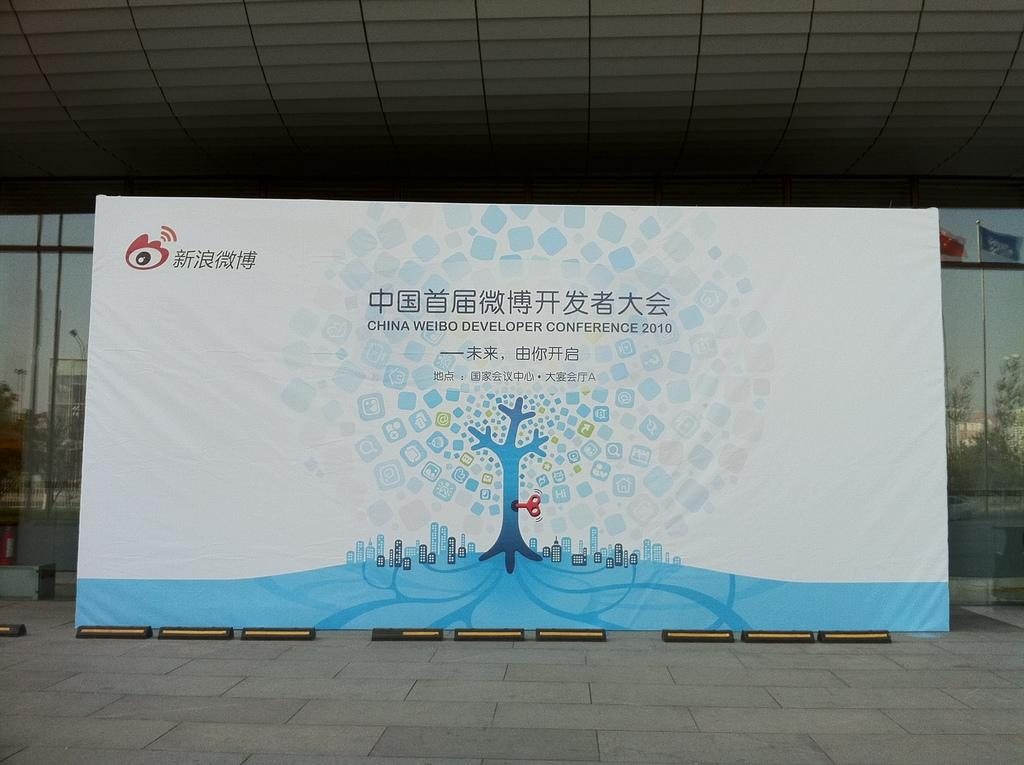What is the main object in the image? There is a flex in the image. What color is the flex? The flex is white in color. What can be found on the surface of the flex? There is text on the flex. What can be seen in the background of the image? There is a glass wall in the background of the image. What type of order is being processed in the image? There is no indication of an order being processed in the image; it features a white flex with text and a glass wall in the background. What kind of agreement is being signed in the image? There is no indication of an agreement being signed in the image; it features a white flex with text and a glass wall in the background. 